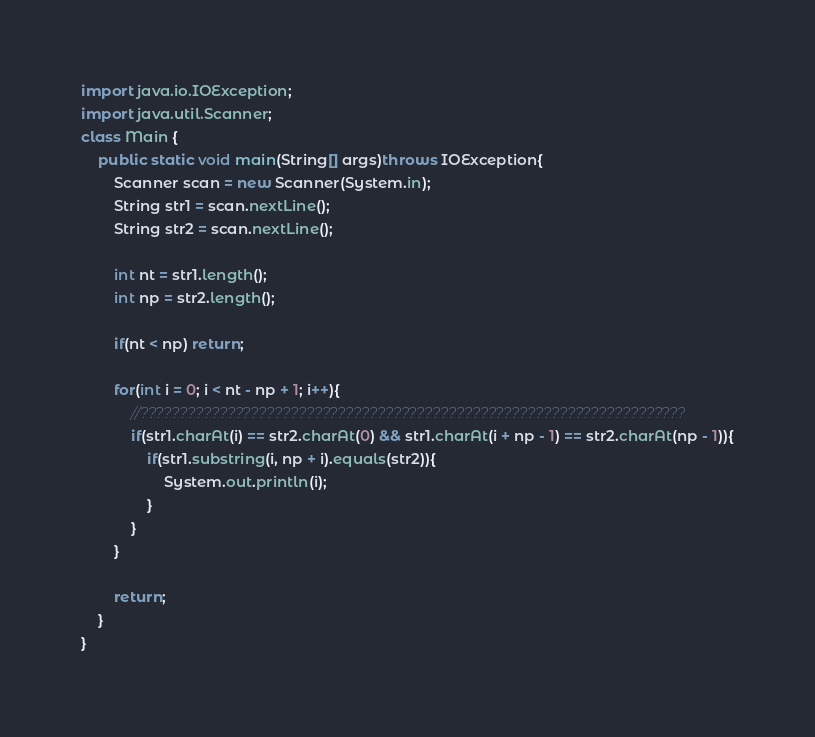<code> <loc_0><loc_0><loc_500><loc_500><_Java_>import java.io.IOException;
import java.util.Scanner;
class Main {
  	public static void main(String[] args)throws IOException{
		Scanner scan = new Scanner(System.in);
		String str1 = scan.nextLine();
		String str2 = scan.nextLine();
		
		int nt = str1.length();
		int np = str2.length();
		
		if(nt < np) return;
		
		for(int i = 0; i < nt - np + 1; i++){
			//?????????????????????????????????????????????????????????????????????
			if(str1.charAt(i) == str2.charAt(0) && str1.charAt(i + np - 1) == str2.charAt(np - 1)){
				if(str1.substring(i, np + i).equals(str2)){
					System.out.println(i);
				}
			}
		}
		
		return;
	}
} </code> 